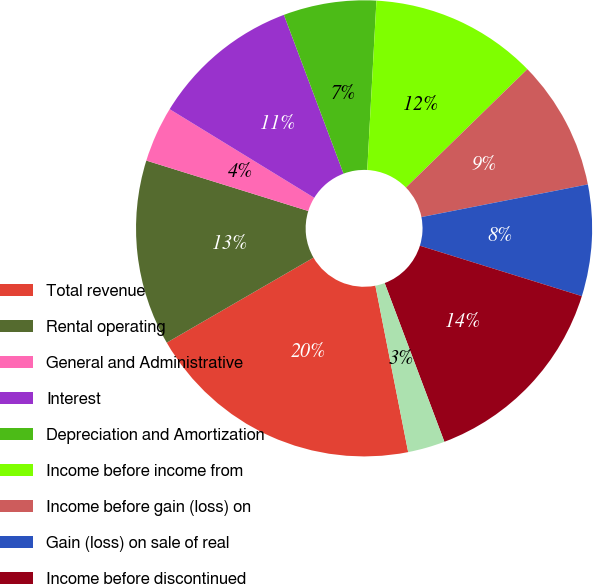Convert chart. <chart><loc_0><loc_0><loc_500><loc_500><pie_chart><fcel>Total revenue<fcel>Rental operating<fcel>General and Administrative<fcel>Interest<fcel>Depreciation and Amortization<fcel>Income before income from<fcel>Income before gain (loss) on<fcel>Gain (loss) on sale of real<fcel>Income before discontinued<fcel>Discontinued operations net of<nl><fcel>19.74%<fcel>13.16%<fcel>3.95%<fcel>10.53%<fcel>6.58%<fcel>11.84%<fcel>9.21%<fcel>7.89%<fcel>14.47%<fcel>2.63%<nl></chart> 